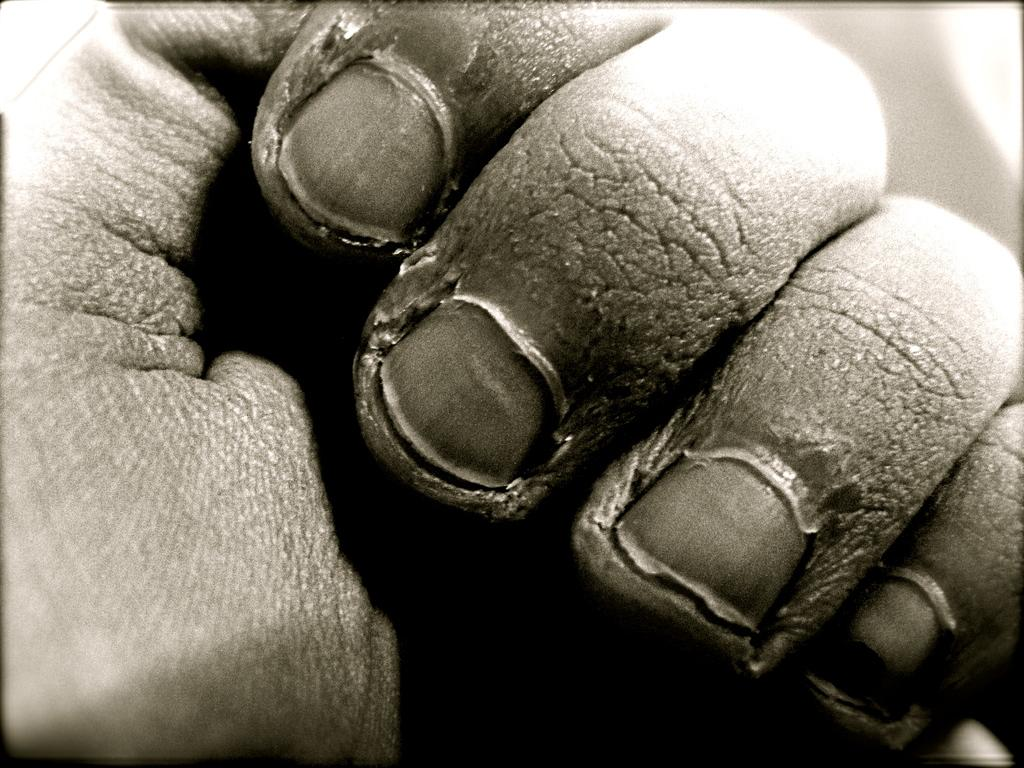What part of a person's body is visible in the image? There is a person's hand visible in the image. What type of bird is perched on the person's hand in the image? There is no bird present in the image; only a person's hand is visible. 